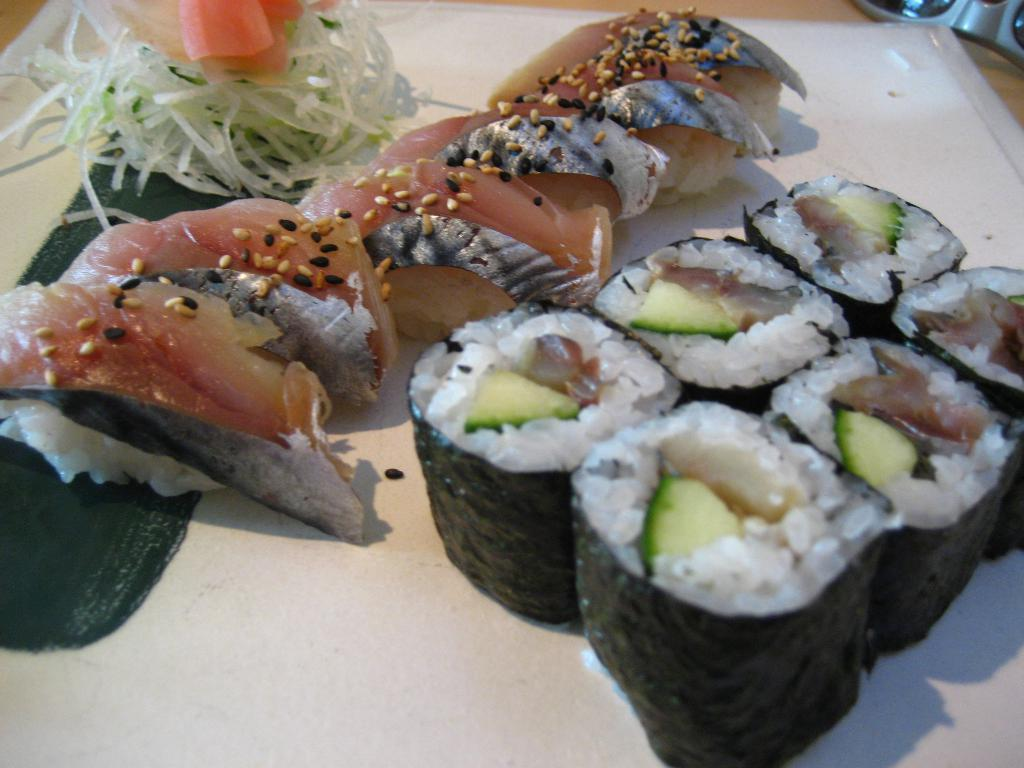What type of food can be seen in the image? There is sushi and other Thai food in the image. How is the food arranged in the image? The food is placed on a plate. What game is being played in the image? There is no game being played in the image; it features food on a plate. What type of discussion is taking place in the image? There is no discussion taking place in the image; it features food on a plate. 